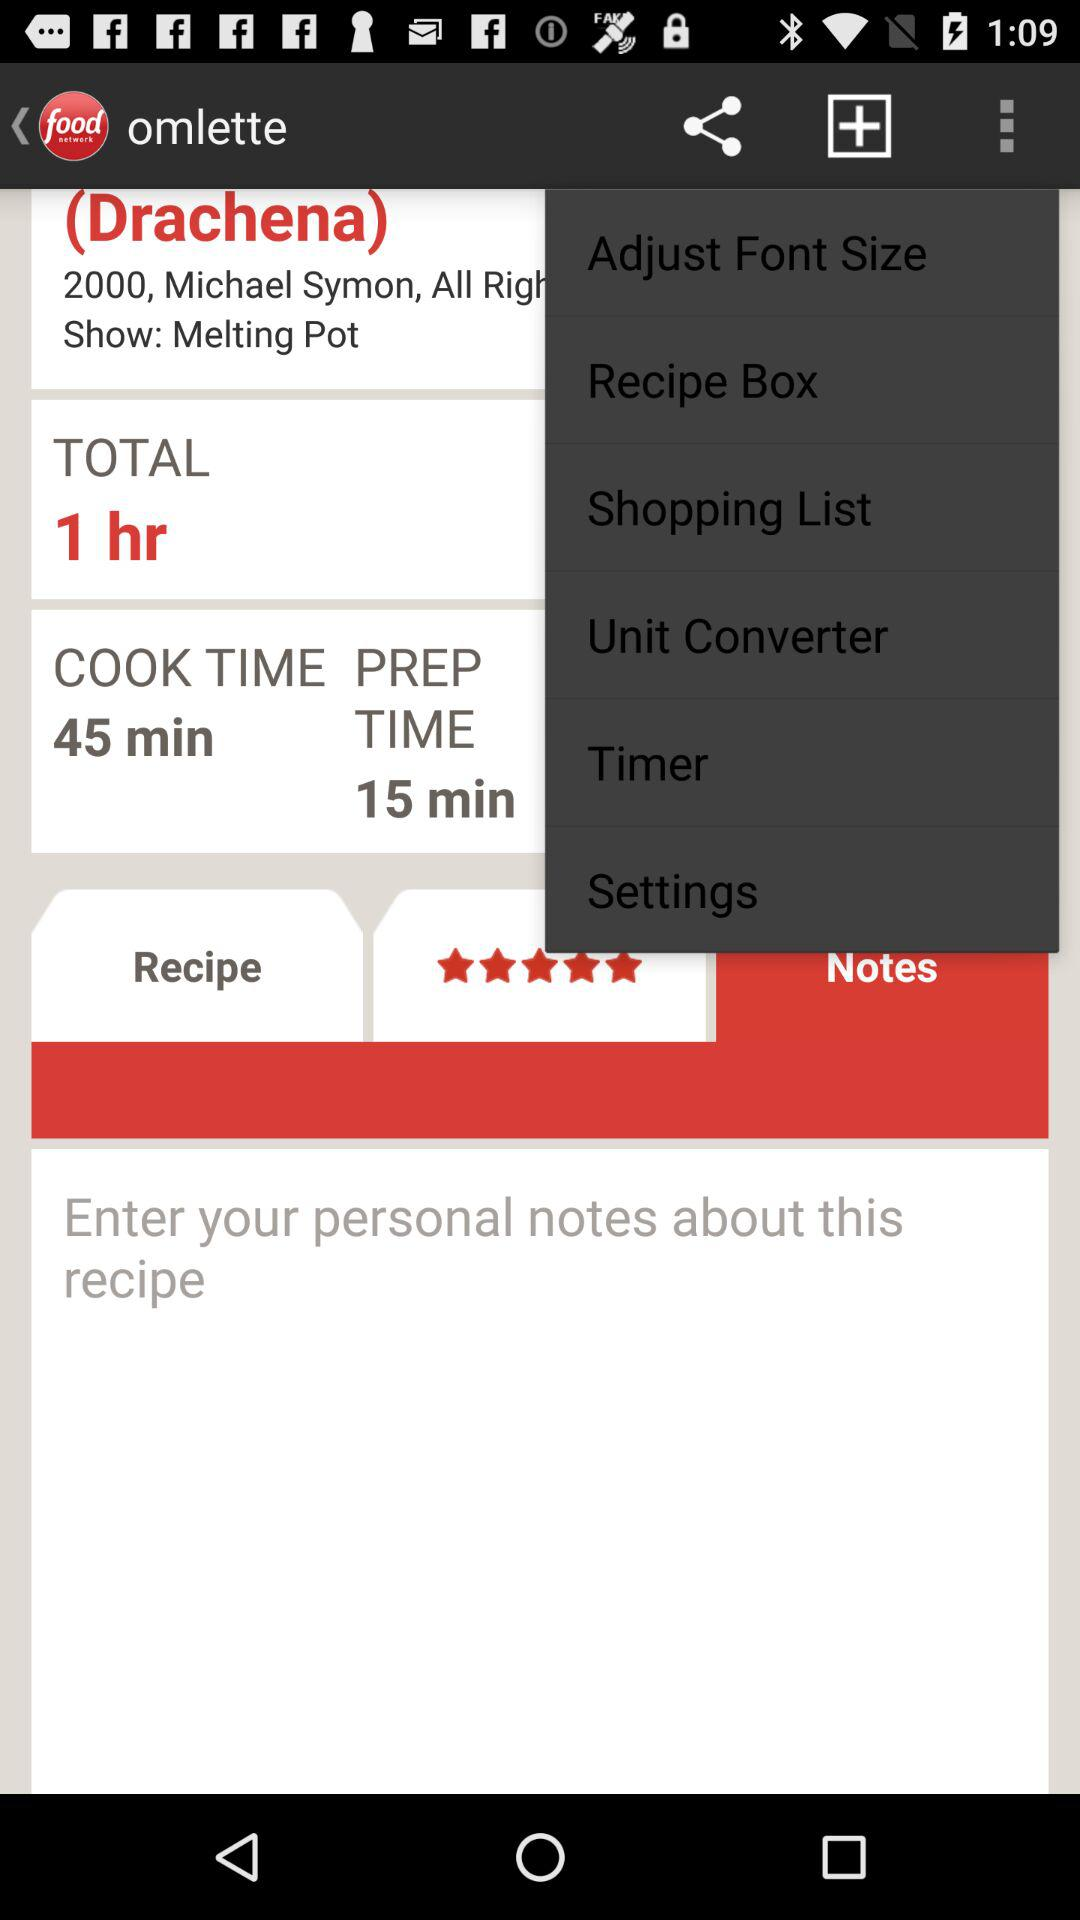What is the cooking time? The cooking time is 45 minutes. 